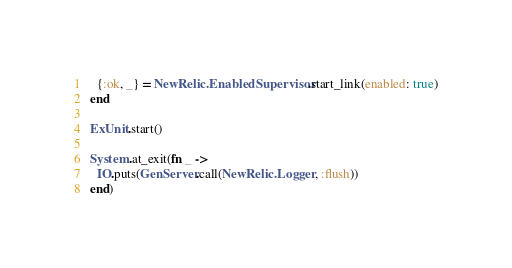<code> <loc_0><loc_0><loc_500><loc_500><_Elixir_>  {:ok, _} = NewRelic.EnabledSupervisor.start_link(enabled: true)
end

ExUnit.start()

System.at_exit(fn _ ->
  IO.puts(GenServer.call(NewRelic.Logger, :flush))
end)
</code> 